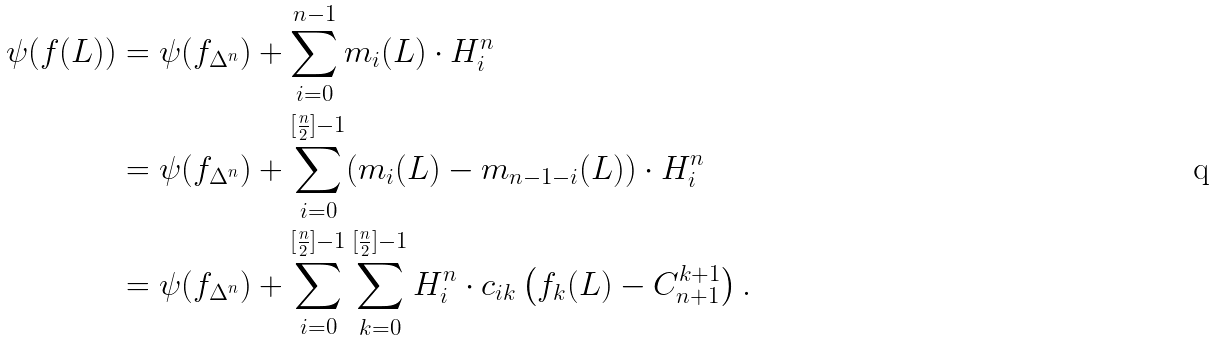Convert formula to latex. <formula><loc_0><loc_0><loc_500><loc_500>\psi ( f ( L ) ) & = \psi ( f _ { \Delta ^ { n } } ) + \sum ^ { n - 1 } _ { i = 0 } m _ { i } ( L ) \cdot H ^ { n } _ { i } \\ & = \psi ( f _ { \Delta ^ { n } } ) + \sum ^ { [ \frac { n } { 2 } ] - 1 } _ { i = 0 } ( m _ { i } ( L ) - m _ { n - 1 - i } ( L ) ) \cdot H ^ { n } _ { i } \\ & = \psi ( f _ { \Delta ^ { n } } ) + \sum ^ { [ \frac { n } { 2 } ] - 1 } _ { i = 0 } \sum ^ { [ \frac { n } { 2 } ] - 1 } _ { k = 0 } H ^ { n } _ { i } \cdot c _ { i k } \left ( f _ { k } ( L ) - C ^ { k + 1 } _ { n + 1 } \right ) .</formula> 